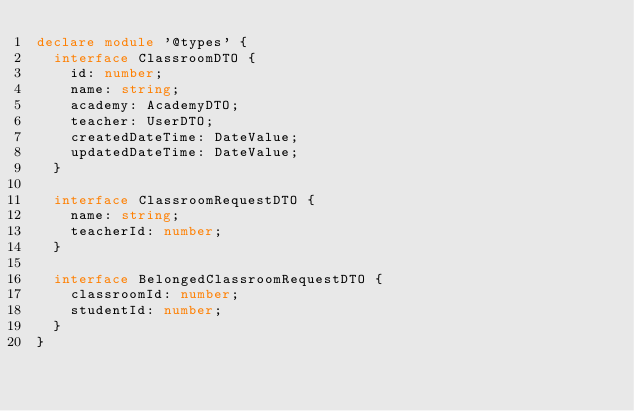Convert code to text. <code><loc_0><loc_0><loc_500><loc_500><_TypeScript_>declare module '@types' {
  interface ClassroomDTO {
    id: number;
    name: string;
    academy: AcademyDTO;
    teacher: UserDTO;
    createdDateTime: DateValue;
    updatedDateTime: DateValue;
  }

  interface ClassroomRequestDTO {
    name: string;
    teacherId: number;
  }

  interface BelongedClassroomRequestDTO {
    classroomId: number;
    studentId: number;
  }
}
</code> 